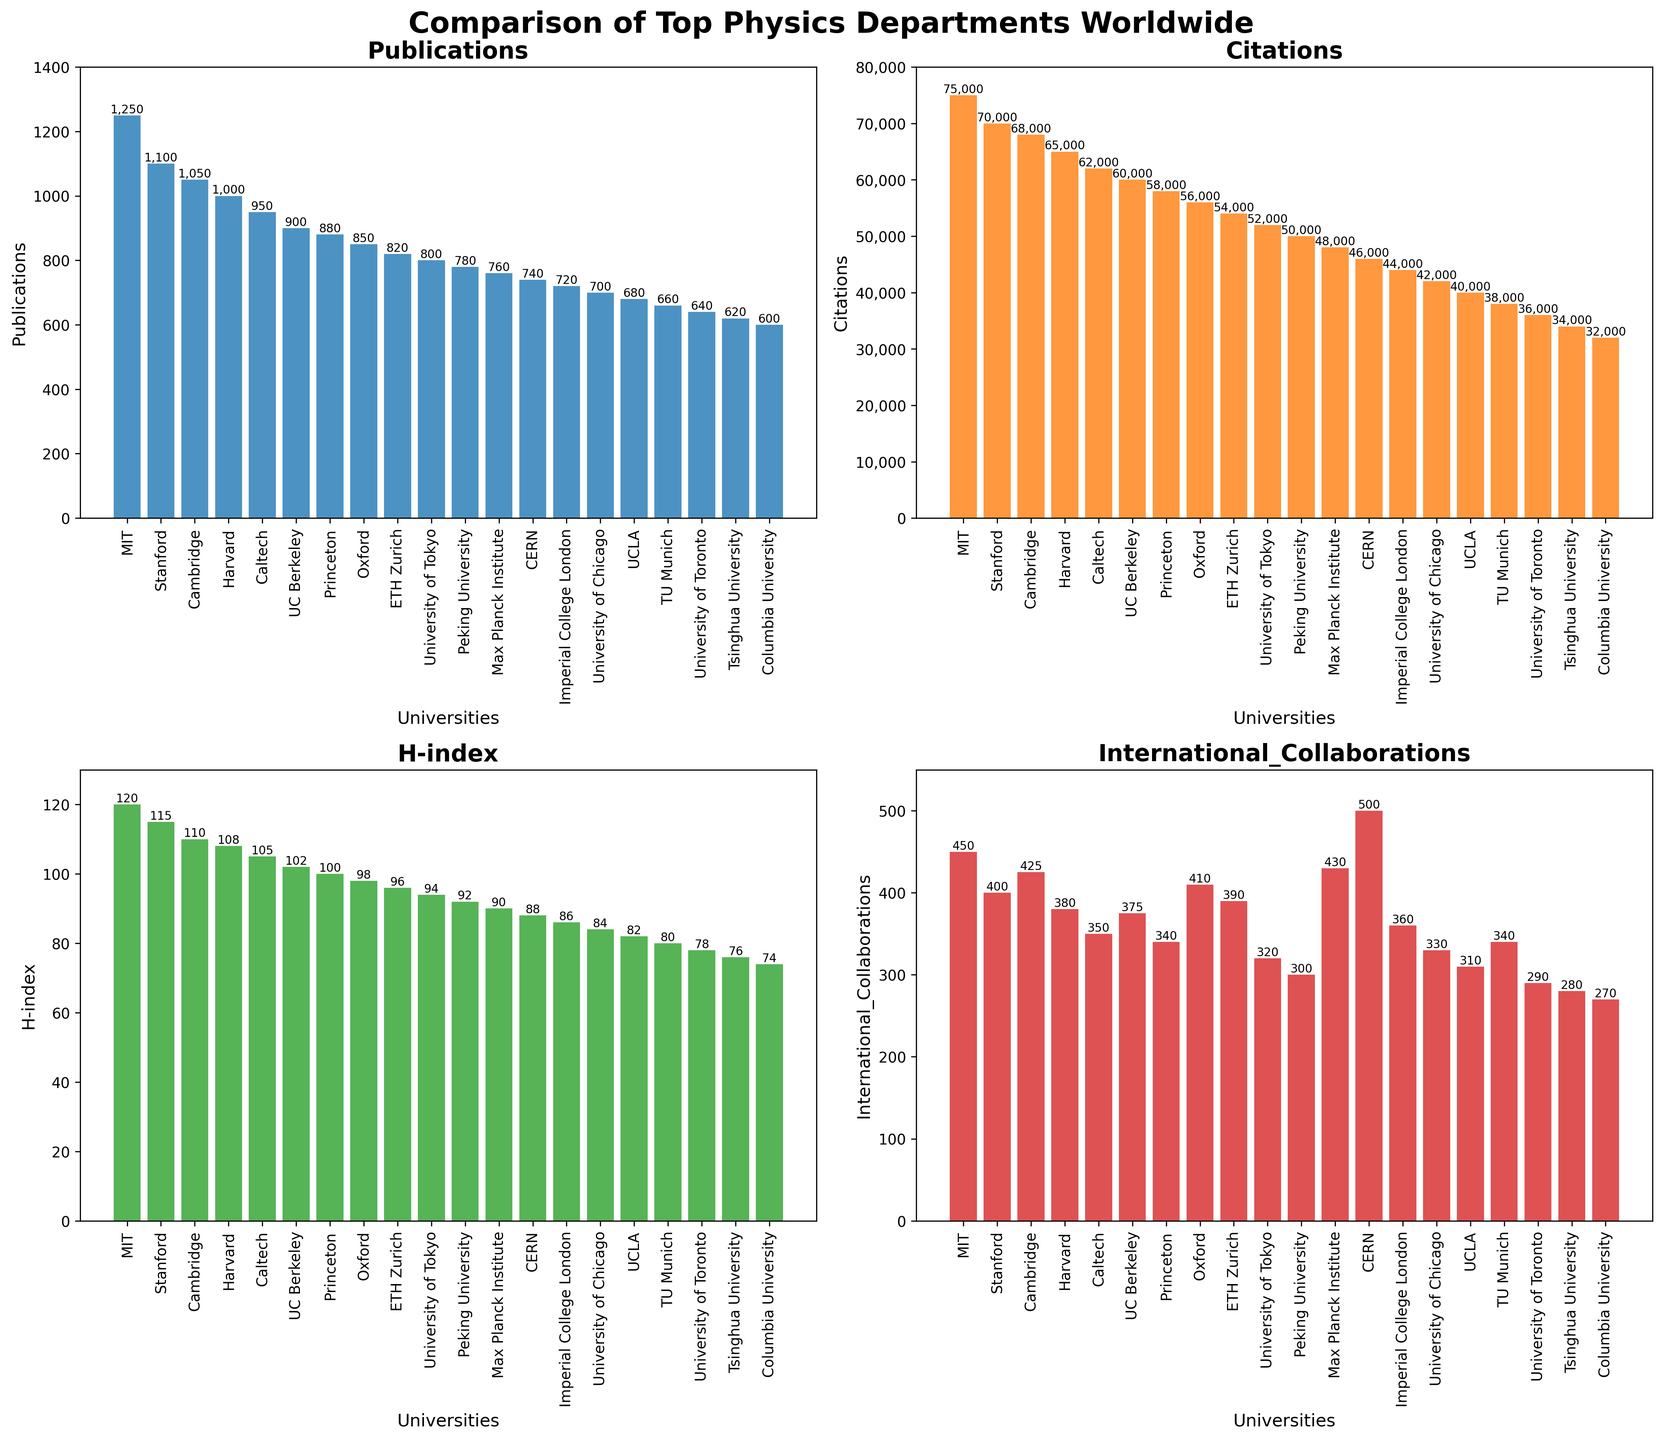Which university has the highest number of publications? Look at the 'Publications' subplot and identify the bar with the greatest height. MIT's bar is the tallest.
Answer: MIT How many more citations does MIT have compared to Stanford? Check the 'Citations' subplot. MIT has 75,000 citations and Stanford has 70,000. Calculate the difference: 75,000 - 70,000 = 5,000
Answer: 5,000 Which university has the lowest H-index? Check the 'H-index' subplot and find the bar with the shortest height. Columbia University's bar is the shortest.
Answer: Columbia University How does the number of international collaborations at CERN compare to the number at Oxford? Look at the 'International Collaborations' subplot. CERN has 500 collaborations, while Oxford has 410.
Answer: CERN has more collaborations (500 vs. 410) Calculate the average number of publications among the top 5 universities. Sum the publications of the top 5 universities (1250 + 1100 + 1050 + 1000 + 950) and divide by 5. Average = (1250 + 1100 + 1050 + 1000 + 950) / 5 = 1070
Answer: 1070 Which two universities have an equal number of international collaborations? Check the 'International Collaborations' subplot for bars of equal height. Princeton and TU Munich both have 340 collaborations.
Answer: Princeton and TU Munich What is the combined H-index of Harvard and Caltech? Check the 'H-index' subplot. Harvard has a H-index of 108 and Caltech has 105. Sum them: 108 + 105 = 213
Answer: 213 Which university's bar in the 'Publications' subplot is closest in height to the bar representing the number of international collaborations at CERN? Check the 'Publications' subplot and compare heights with the 500 collaborations at CERN in the 'International Collaborations' subplot. University of Tokyo has 800 publications which is closest.
Answer: University of Tokyo By how much does the number of citations at UC Berkeley exceed the sum of citations at Tsinghua University and Columbia University? UC Berkeley has 60,000 citations. Tsinghua University has 34,000 and Columbia University has 32,000. Compute the sum and difference: (34,000 + 32,000) = 66,000; 60,000 - 66,000 = -6,000
Answer: -6,000 